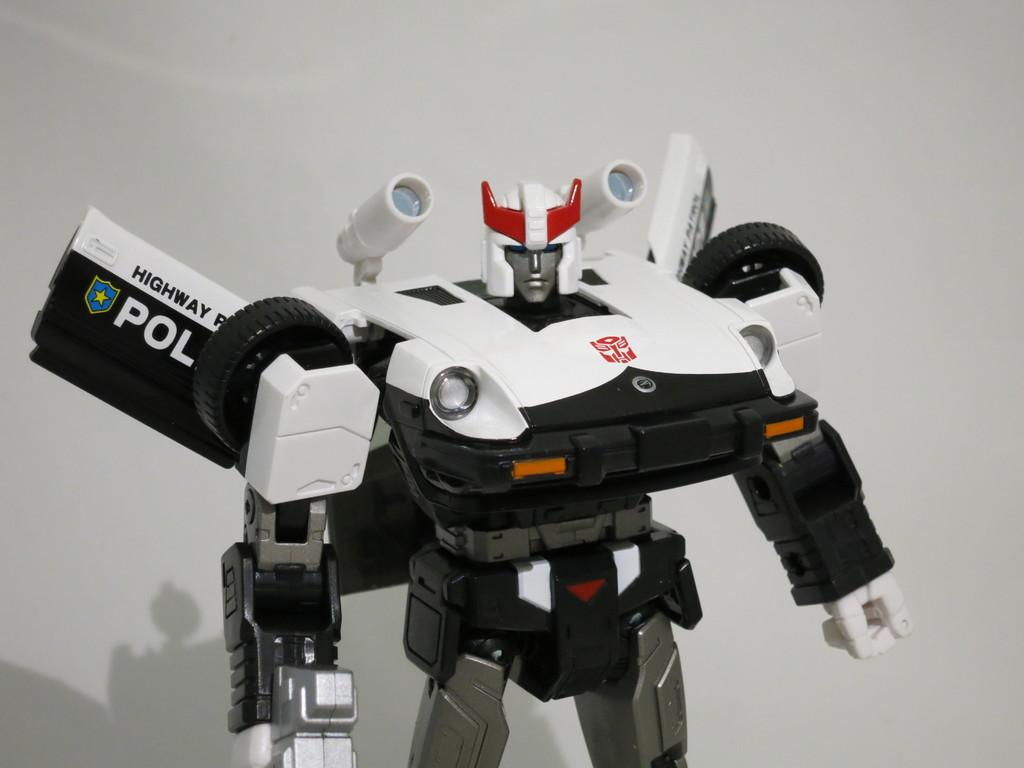<image>
Present a compact description of the photo's key features. white and black robot toy that reads highway patrol 